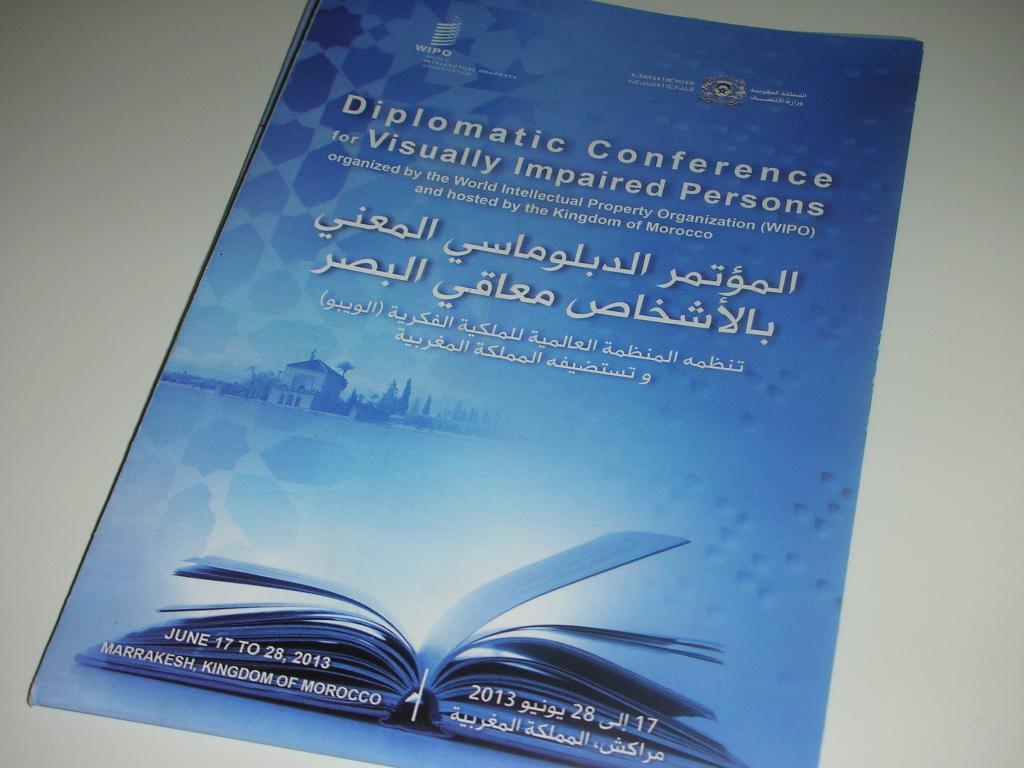Where is this book from?
Offer a very short reply. Morocco. 